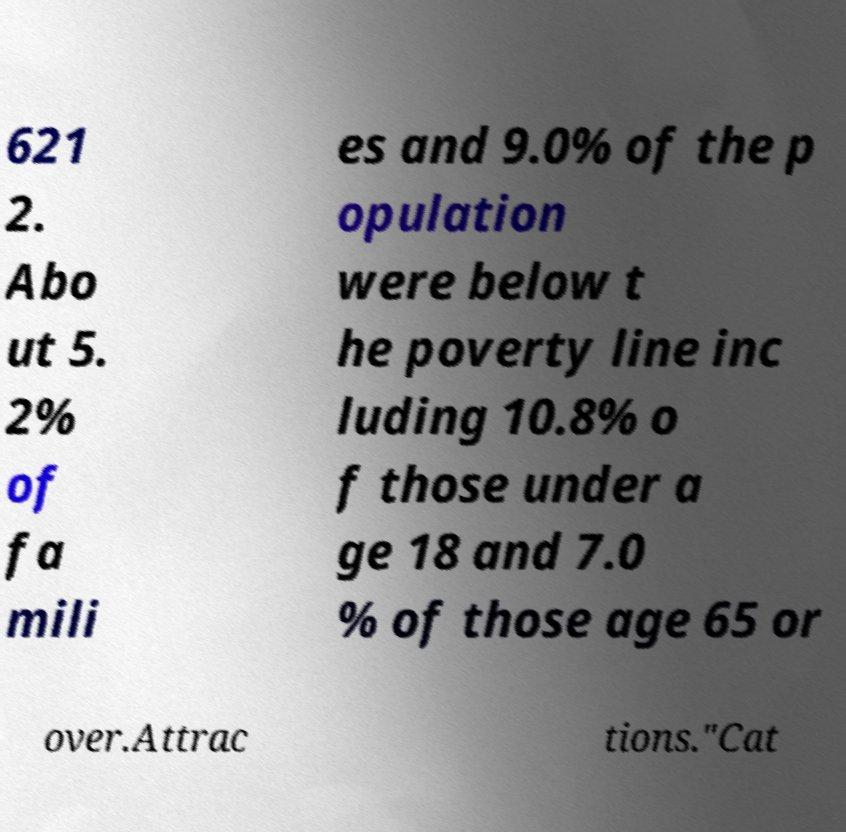What messages or text are displayed in this image? I need them in a readable, typed format. 621 2. Abo ut 5. 2% of fa mili es and 9.0% of the p opulation were below t he poverty line inc luding 10.8% o f those under a ge 18 and 7.0 % of those age 65 or over.Attrac tions."Cat 